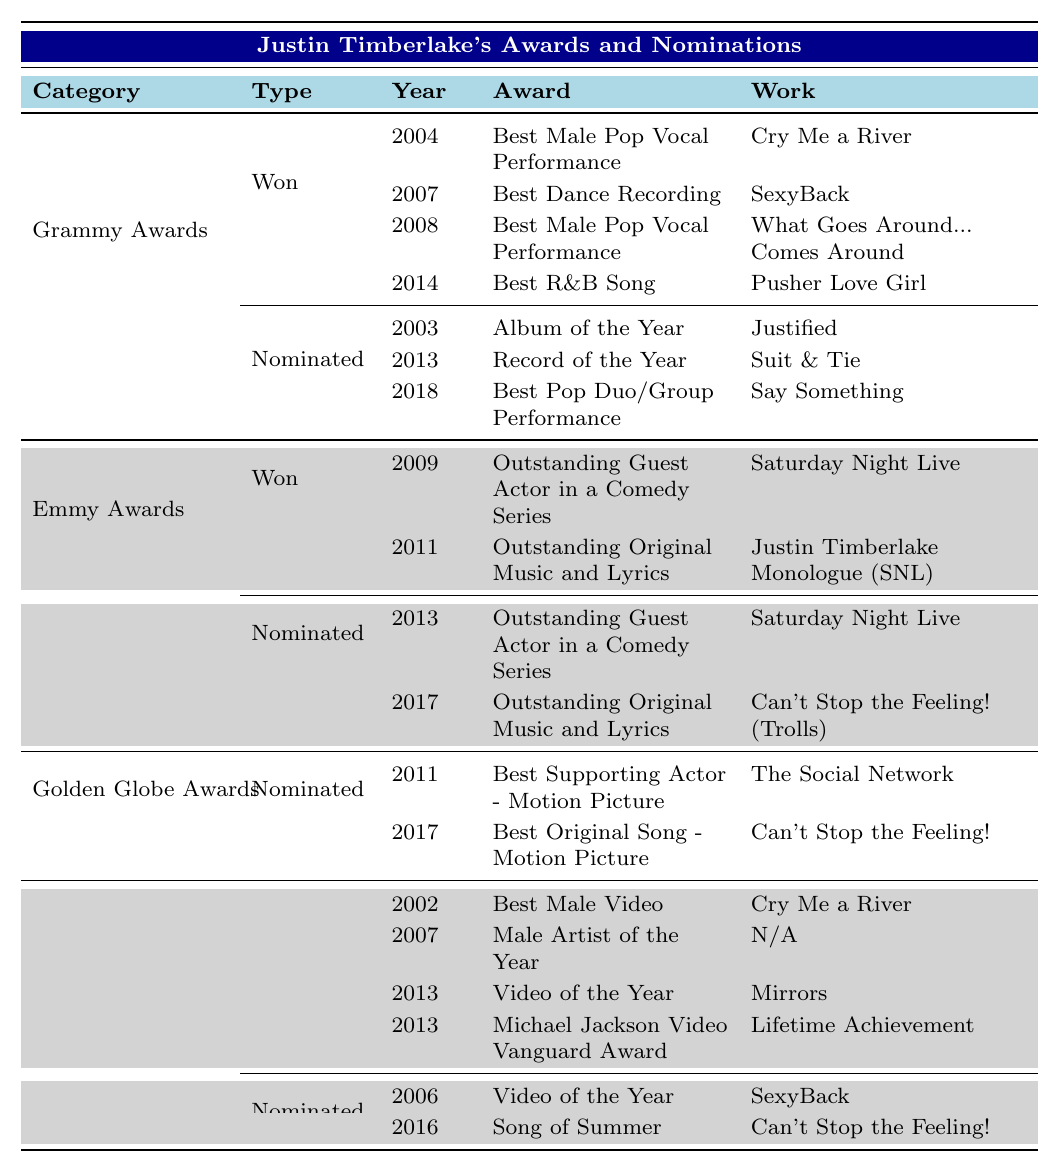What award did Justin Timberlake win in 2004? The table shows that he won the "Best Male Pop Vocal Performance" award for "Cry Me a River" in 2004 under the Grammy Awards category.
Answer: Best Male Pop Vocal Performance How many Grammy Awards has Justin Timberlake won? By reviewing the Grammy Awards section of the table, he has won a total of 4 awards.
Answer: 4 In what year did Justin Timberlake win the Emmy Award for Outstanding Guest Actor in a Comedy Series? The table specifies that he won this award in 2009.
Answer: 2009 Which award did Justin Timberlake win in 2013 at the MTV Video Music Awards? According to the table, he won the "Video of the Year" for "Mirrors" in 2013.
Answer: Video of the Year How many nominations did Justin Timberlake receive for the Grammy Awards? The table indicates that he was nominated 3 times for the Grammy Awards.
Answer: 3 Did Justin Timberlake win an Emmy Award in 2017? The table states that he was nominated for an Emmy Award in 2017, but he did not win it.
Answer: No What is the total number of Emmy Awards won by Justin Timberlake? From the Emmy Awards section, he won 2 awards.
Answer: 2 In which category did Justin Timberlake receive his first Grammy nomination? According to the table, his first Grammy nomination was for "Album of the Year" for "Justified" in 2003.
Answer: Album of the Year What is the difference between the total number of Grammy Awards won and the total number of Emmy Awards won by Justin Timberlake? He won 4 Grammy Awards and 2 Emmy Awards. The difference is 4 - 2 = 2.
Answer: 2 Did Justin Timberlake win more awards in MTV Video Music Awards than in Grammy Awards? The table states that he has won 4 awards at the MTV Video Music Awards and 4 at the Grammy Awards, so they are equal.
Answer: No Which category has the most number of awards won by Justin Timberlake? The Grammy Awards section shows 4 won awards, which is the highest compared to the other categories.
Answer: Grammy Awards 